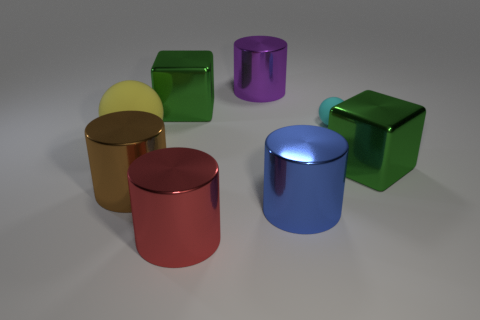Are there the same number of purple shiny things right of the small cyan ball and big red cylinders?
Your answer should be very brief. No. There is a purple metal thing; are there any big purple metallic objects on the left side of it?
Give a very brief answer. No. There is a blue thing; is it the same shape as the rubber thing to the left of the big purple cylinder?
Your answer should be compact. No. There is a large thing that is the same material as the tiny thing; what color is it?
Provide a short and direct response. Yellow. What is the color of the small sphere?
Your answer should be very brief. Cyan. Does the big yellow thing have the same material as the green object to the left of the cyan matte ball?
Offer a terse response. No. How many spheres are left of the large purple cylinder and on the right side of the big yellow sphere?
Offer a very short reply. 0. The brown metal thing that is the same size as the purple cylinder is what shape?
Offer a very short reply. Cylinder. Is there a large block behind the big metal cube that is to the left of the large green shiny object that is on the right side of the big purple object?
Offer a terse response. No. Does the small object have the same color as the shiny cube in front of the big yellow rubber thing?
Provide a succinct answer. No. 